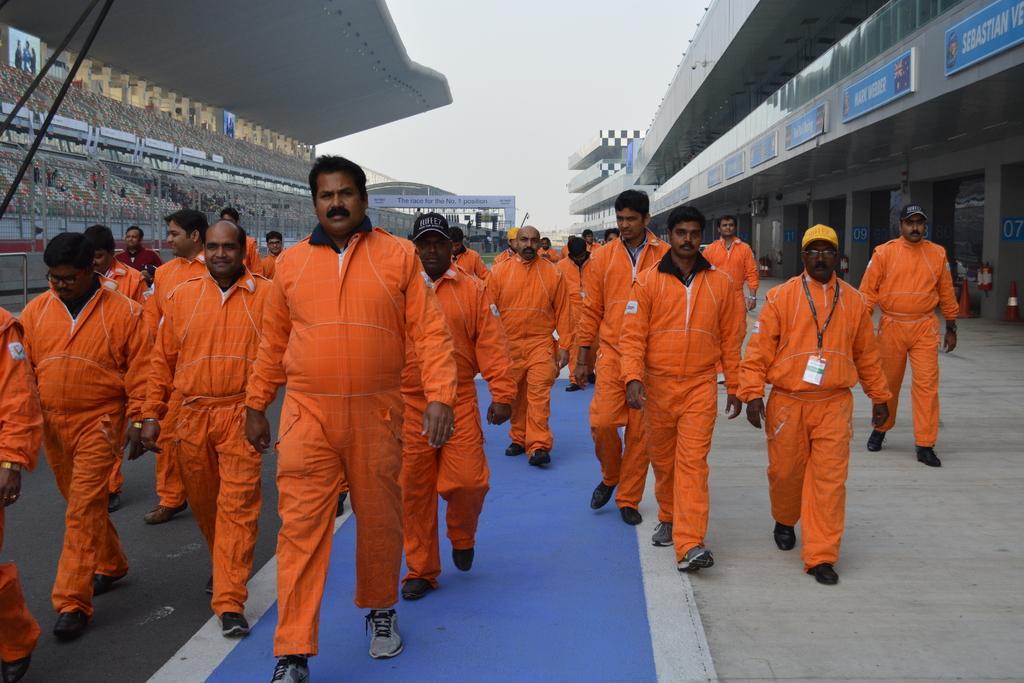Describe this image in one or two sentences. This picture is clicked outside. In the foreground we can see the group of people wearing costumes and walking on the ground. On both the sides we can see the buildings. On the left we can see the group of people and the depictions of people on the objects which seems to be the digital screens. In the background we can see the sky, buildings and the text on an object and we can see some other items. On the right we can see the safety cones and the fire extinguishers and the text on the boards. 